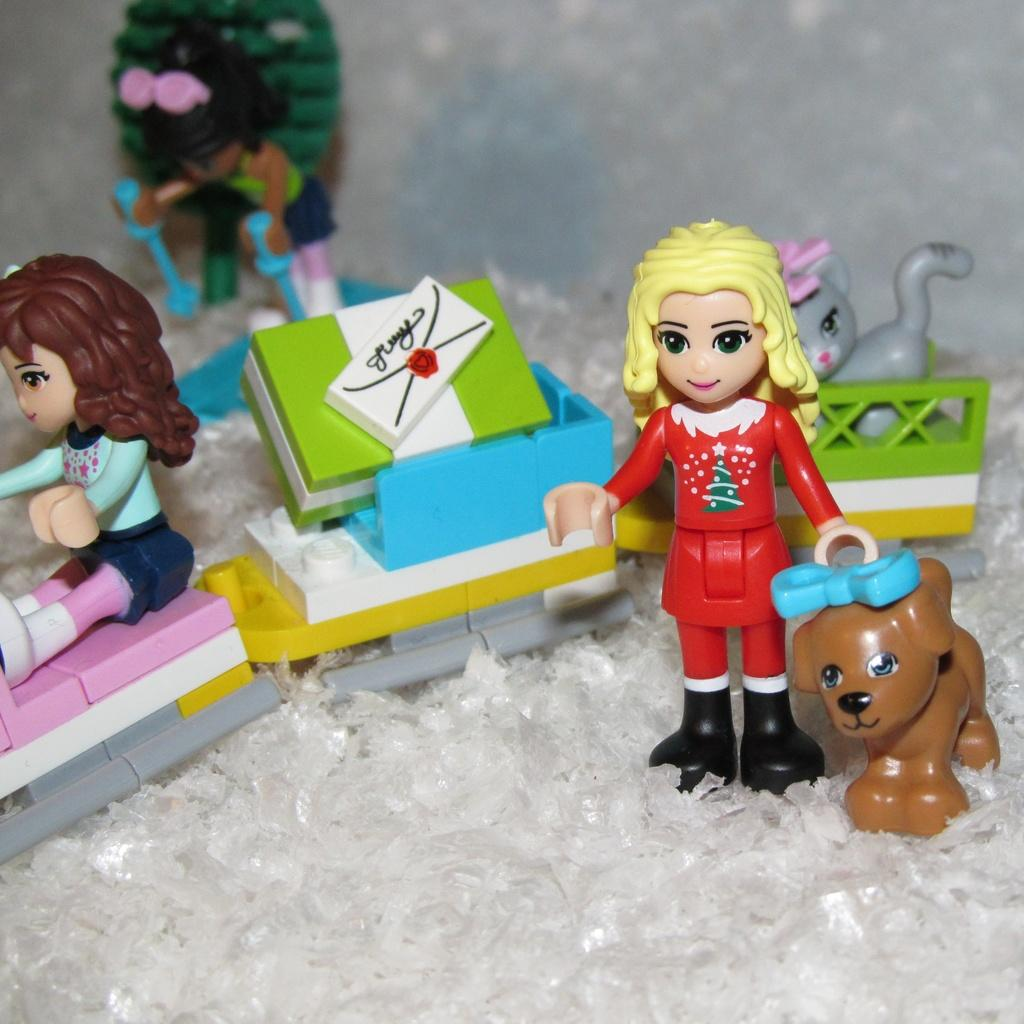What type of objects are in the image? There are plastic toys in the image. Where are the plastic toys located? The plastic toys are on a path. Is there a squirrel carrying a tray in the image? No, there is no squirrel or tray present in the image. 